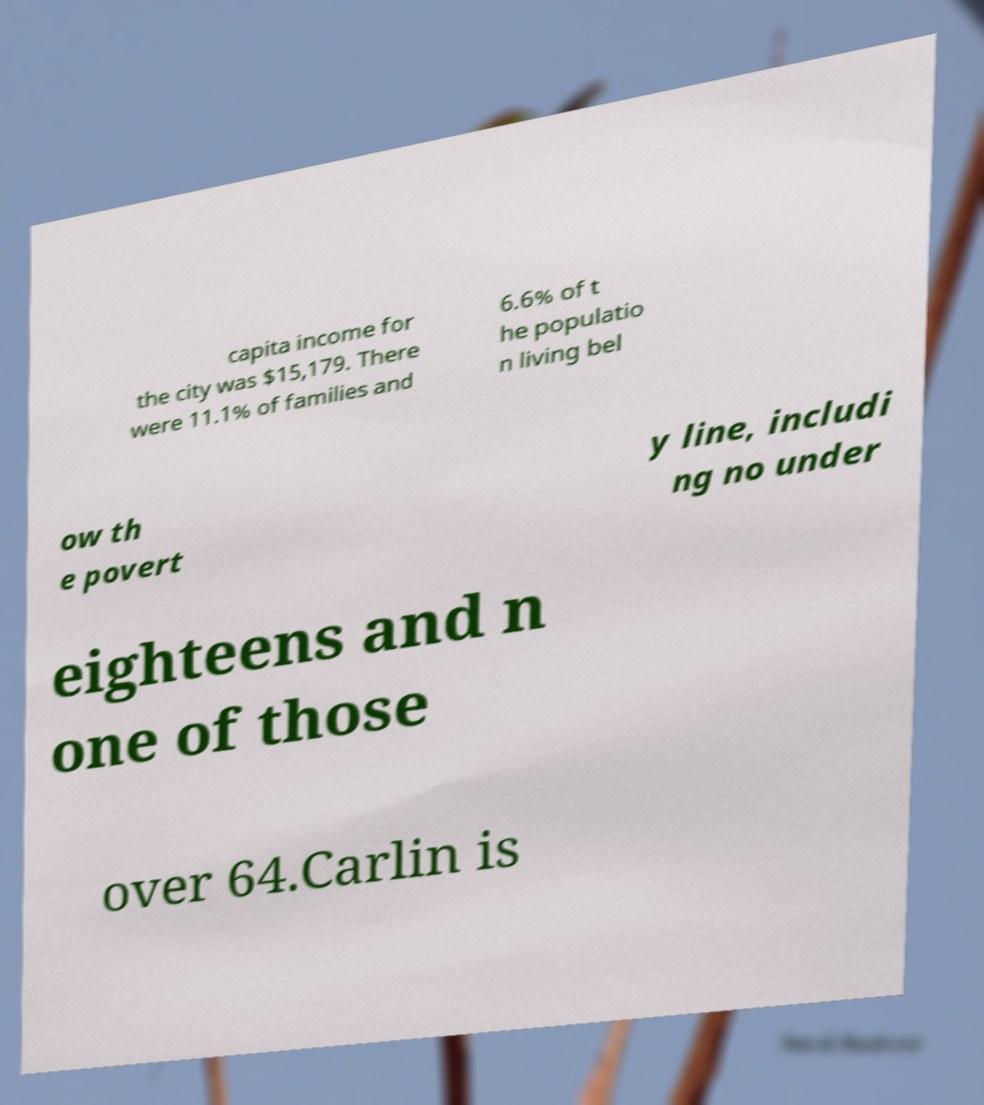For documentation purposes, I need the text within this image transcribed. Could you provide that? capita income for the city was $15,179. There were 11.1% of families and 6.6% of t he populatio n living bel ow th e povert y line, includi ng no under eighteens and n one of those over 64.Carlin is 